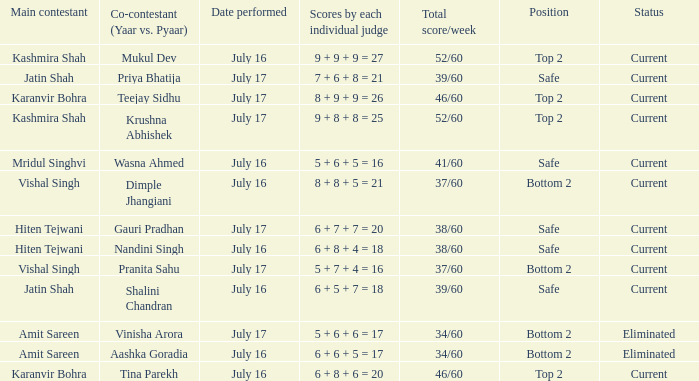In which position did the team end up with a score of 41/60? Safe. 